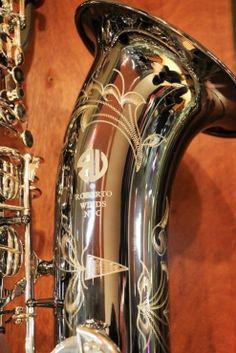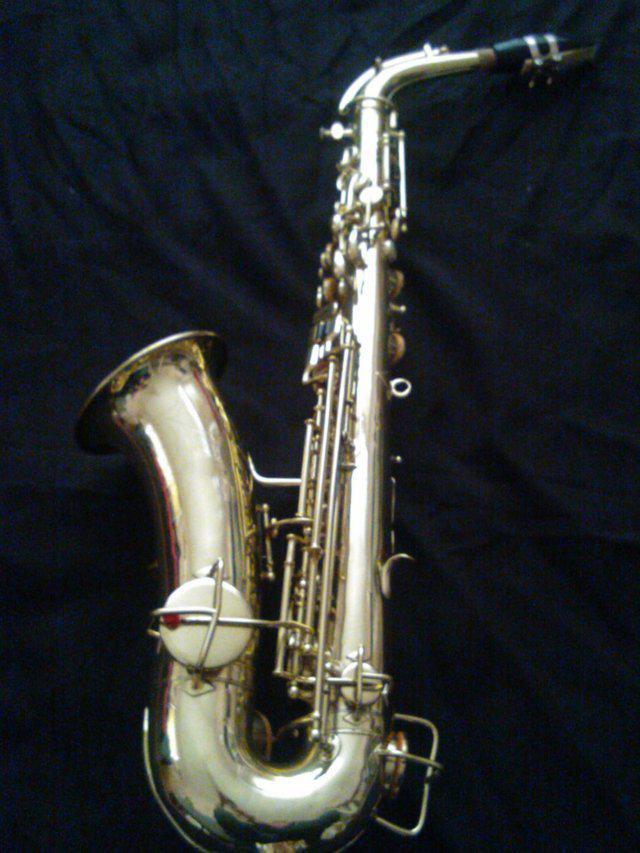The first image is the image on the left, the second image is the image on the right. Examine the images to the left and right. Is the description "The mouthpiece of the instrument is disconnected and laying next to the instrument in the left image." accurate? Answer yes or no. No. 